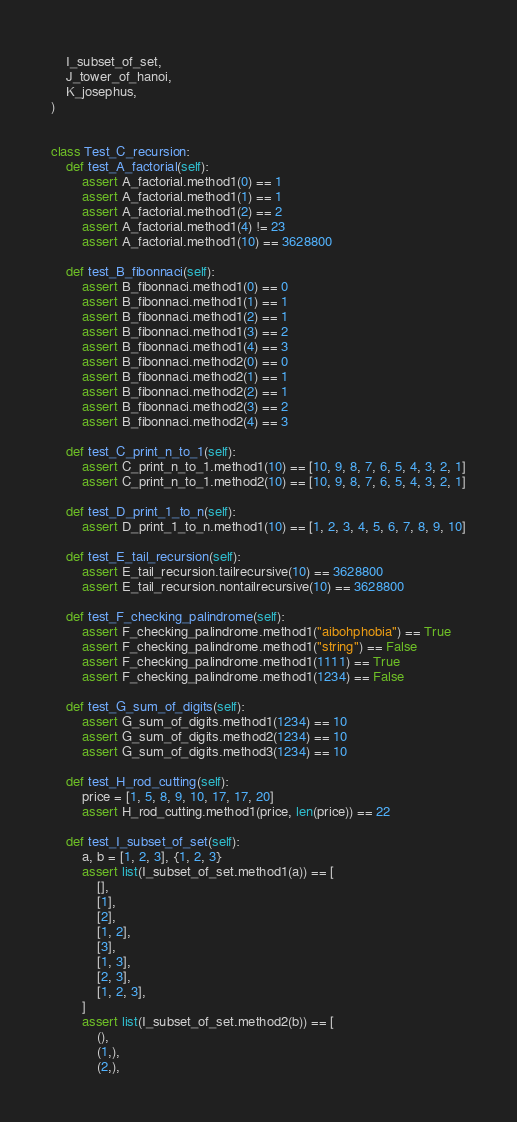<code> <loc_0><loc_0><loc_500><loc_500><_Python_>    I_subset_of_set,
    J_tower_of_hanoi,
    K_josephus,
)


class Test_C_recursion:
    def test_A_factorial(self):
        assert A_factorial.method1(0) == 1
        assert A_factorial.method1(1) == 1
        assert A_factorial.method1(2) == 2
        assert A_factorial.method1(4) != 23
        assert A_factorial.method1(10) == 3628800

    def test_B_fibonnaci(self):
        assert B_fibonnaci.method1(0) == 0
        assert B_fibonnaci.method1(1) == 1
        assert B_fibonnaci.method1(2) == 1
        assert B_fibonnaci.method1(3) == 2
        assert B_fibonnaci.method1(4) == 3
        assert B_fibonnaci.method2(0) == 0
        assert B_fibonnaci.method2(1) == 1
        assert B_fibonnaci.method2(2) == 1
        assert B_fibonnaci.method2(3) == 2
        assert B_fibonnaci.method2(4) == 3

    def test_C_print_n_to_1(self):
        assert C_print_n_to_1.method1(10) == [10, 9, 8, 7, 6, 5, 4, 3, 2, 1]
        assert C_print_n_to_1.method2(10) == [10, 9, 8, 7, 6, 5, 4, 3, 2, 1]

    def test_D_print_1_to_n(self):
        assert D_print_1_to_n.method1(10) == [1, 2, 3, 4, 5, 6, 7, 8, 9, 10]

    def test_E_tail_recursion(self):
        assert E_tail_recursion.tailrecursive(10) == 3628800
        assert E_tail_recursion.nontailrecursive(10) == 3628800

    def test_F_checking_palindrome(self):
        assert F_checking_palindrome.method1("aibohphobia") == True
        assert F_checking_palindrome.method1("string") == False
        assert F_checking_palindrome.method1(1111) == True
        assert F_checking_palindrome.method1(1234) == False

    def test_G_sum_of_digits(self):
        assert G_sum_of_digits.method1(1234) == 10
        assert G_sum_of_digits.method2(1234) == 10
        assert G_sum_of_digits.method3(1234) == 10

    def test_H_rod_cutting(self):
        price = [1, 5, 8, 9, 10, 17, 17, 20]
        assert H_rod_cutting.method1(price, len(price)) == 22

    def test_I_subset_of_set(self):
        a, b = [1, 2, 3], {1, 2, 3}
        assert list(I_subset_of_set.method1(a)) == [
            [],
            [1],
            [2],
            [1, 2],
            [3],
            [1, 3],
            [2, 3],
            [1, 2, 3],
        ]
        assert list(I_subset_of_set.method2(b)) == [
            (),
            (1,),
            (2,),</code> 